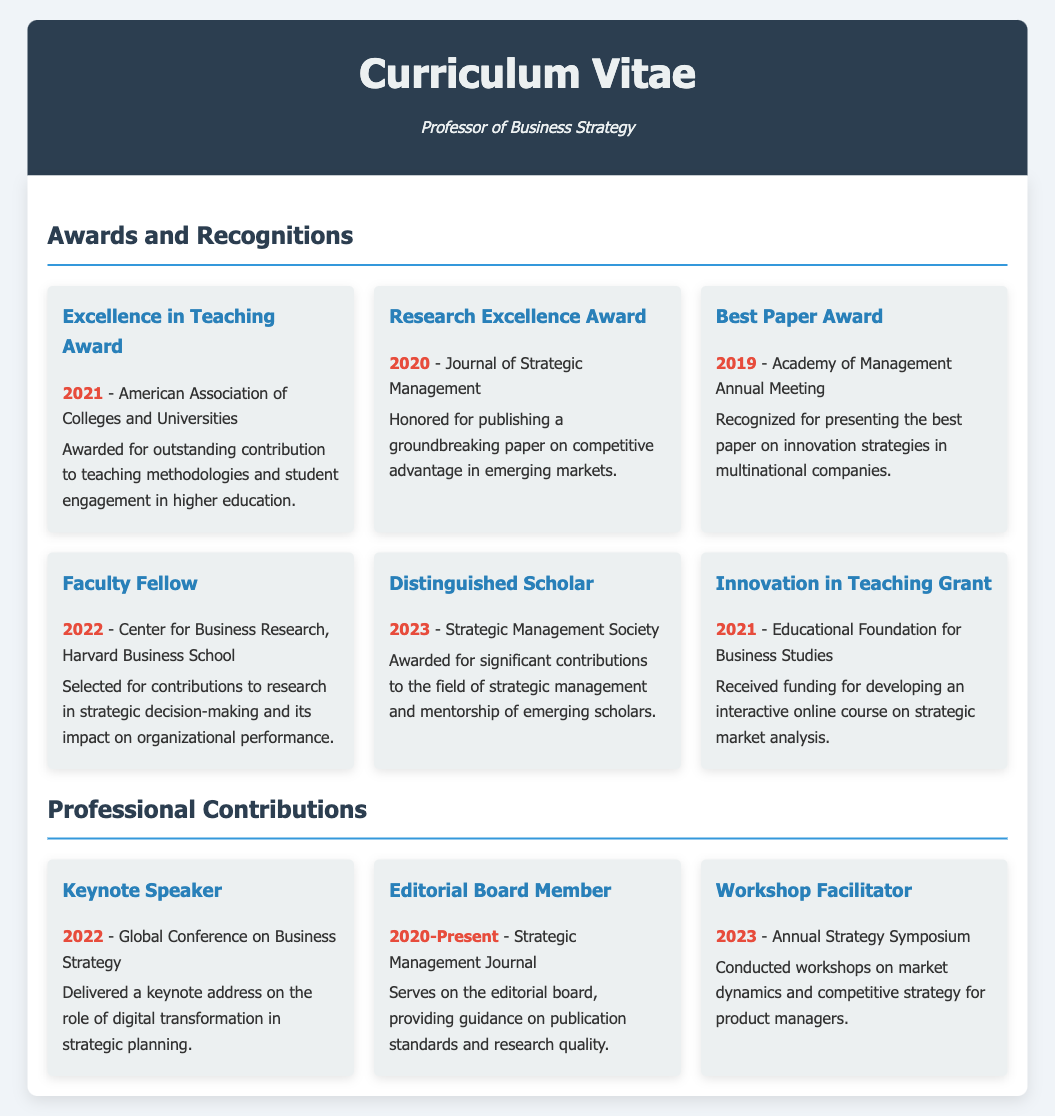what award did the professor receive in 2021? The document lists the "Excellence in Teaching Award" as the award received in 2021.
Answer: Excellence in Teaching Award who awarded the "Research Excellence Award"? The award was given by the "Journal of Strategic Management".
Answer: Journal of Strategic Management what year was the "Best Paper Award" received? According to the document, the "Best Paper Award" was received in 2019.
Answer: 2019 how many awards are listed in the document? The document lists six specific awards under "Awards and Recognitions".
Answer: six which award recognizes contributions to teaching methodologies? The "Excellence in Teaching Award" recognizes contributions to teaching methodologies and student engagement.
Answer: Excellence in Teaching Award what is the most recent award mentioned? The most recent award mentioned in the document is the "Distinguished Scholar" awarded in 2023.
Answer: Distinguished Scholar which institution awarded the "Faculty Fellow" title? The "Faculty Fellow" title was awarded by the "Center for Business Research, Harvard Business School".
Answer: Center for Business Research, Harvard Business School in which year did the professor receive the "Innovation in Teaching Grant"? The document states that the "Innovation in Teaching Grant" was received in 2021.
Answer: 2021 what does the "Best Paper Award" recognition relate to? The "Best Paper Award" relates to presenting the best paper on innovation strategies in multinational companies.
Answer: innovation strategies in multinational companies 